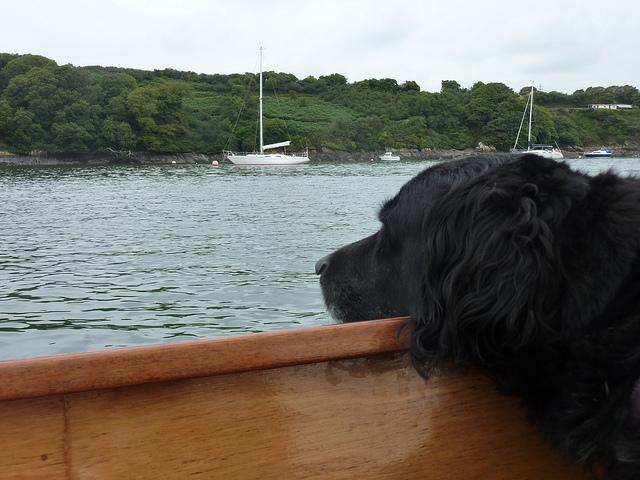What is causing the dog to rest his head on the side of the boat?

Choices:
A) exhaustion
B) laziness
C) command
D) boredom boredom 